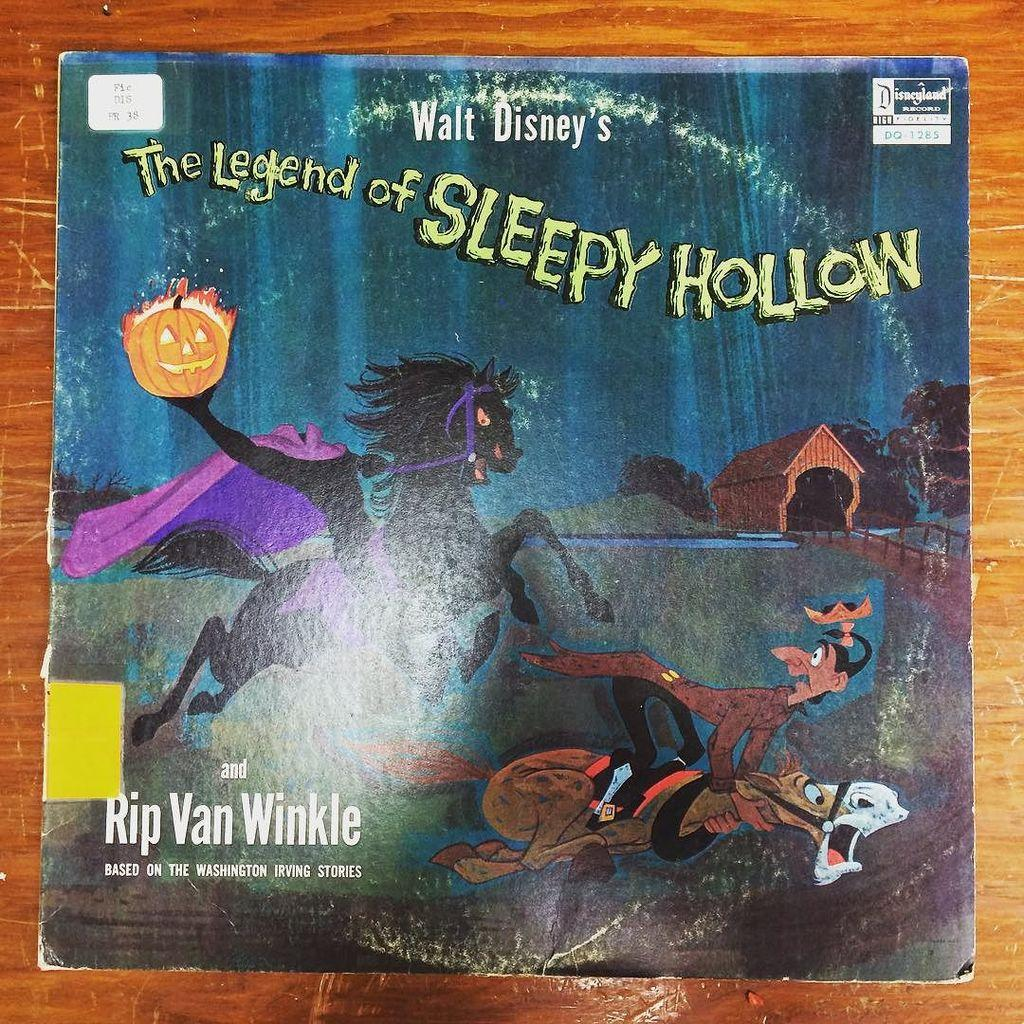Provide a one-sentence caption for the provided image. The legend of sleepy hollow lays on a wooden table. 